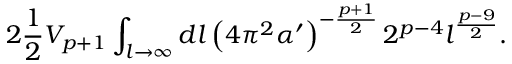<formula> <loc_0><loc_0><loc_500><loc_500>2 \frac { 1 } { 2 } V _ { p + 1 } \int _ { l \to \infty } d l \left ( 4 \pi ^ { 2 } \alpha ^ { \prime } \right ) ^ { - \frac { p + 1 } { 2 } } 2 ^ { p - 4 } l ^ { \frac { p - 9 } { 2 } } .</formula> 